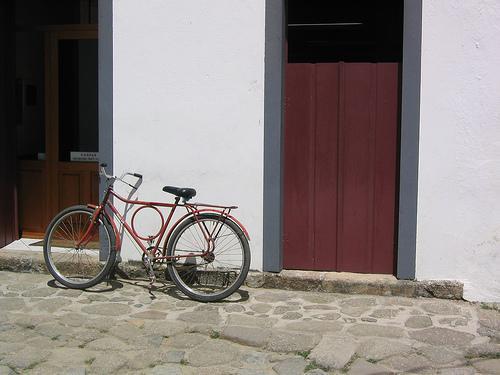How many tires does the bicycle have?
Give a very brief answer. 2. How many tires are there?
Give a very brief answer. 2. How many doors does the building have?
Give a very brief answer. 2. 